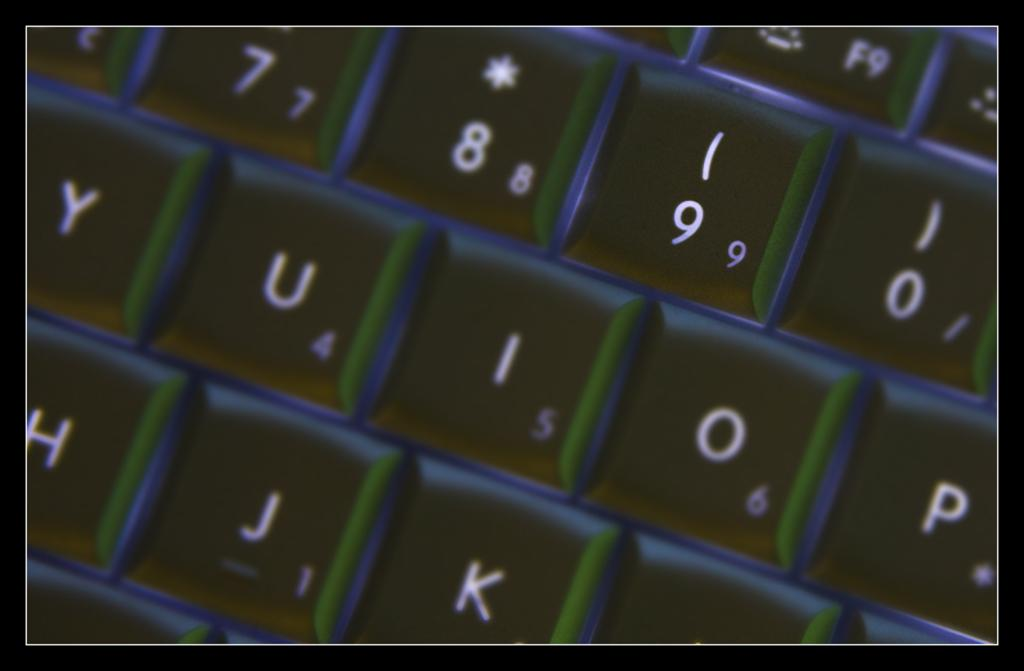<image>
Render a clear and concise summary of the photo. Several keys on a laptop are illuminated, including "U, I, and O.' 